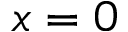Convert formula to latex. <formula><loc_0><loc_0><loc_500><loc_500>x = 0</formula> 